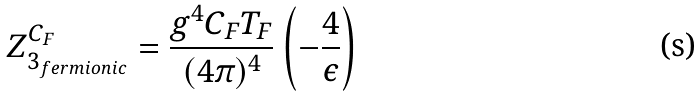Convert formula to latex. <formula><loc_0><loc_0><loc_500><loc_500>Z ^ { C _ { F } } _ { 3 _ { f e r m i o n i c } } = \frac { g ^ { 4 } C _ { F } T _ { F } } { ( 4 \pi ) ^ { 4 } } \left ( - \frac { 4 } { \epsilon } \right )</formula> 